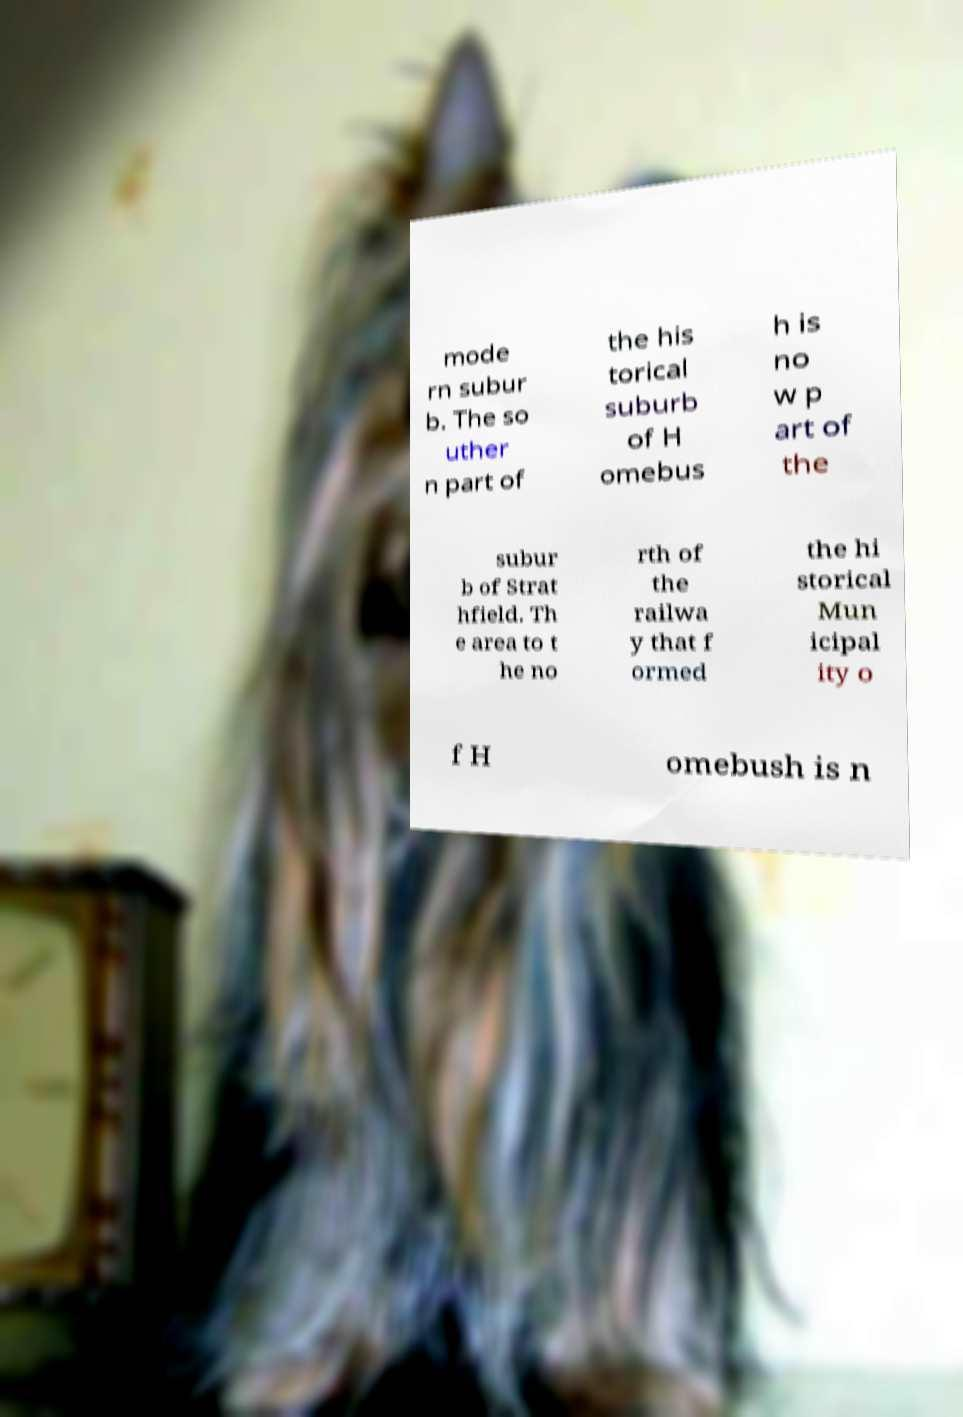Please read and relay the text visible in this image. What does it say? mode rn subur b. The so uther n part of the his torical suburb of H omebus h is no w p art of the subur b of Strat hfield. Th e area to t he no rth of the railwa y that f ormed the hi storical Mun icipal ity o f H omebush is n 